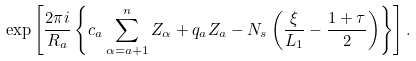Convert formula to latex. <formula><loc_0><loc_0><loc_500><loc_500>\exp \left [ \frac { 2 \pi i } { R _ { a } } \left \{ c _ { a } \sum _ { \alpha = a + 1 } ^ { n } Z _ { \alpha } + q _ { a } Z _ { a } - N _ { s } \left ( \frac { \xi } { L _ { 1 } } - \frac { 1 + \tau } { 2 } \right ) \right \} \right ] .</formula> 